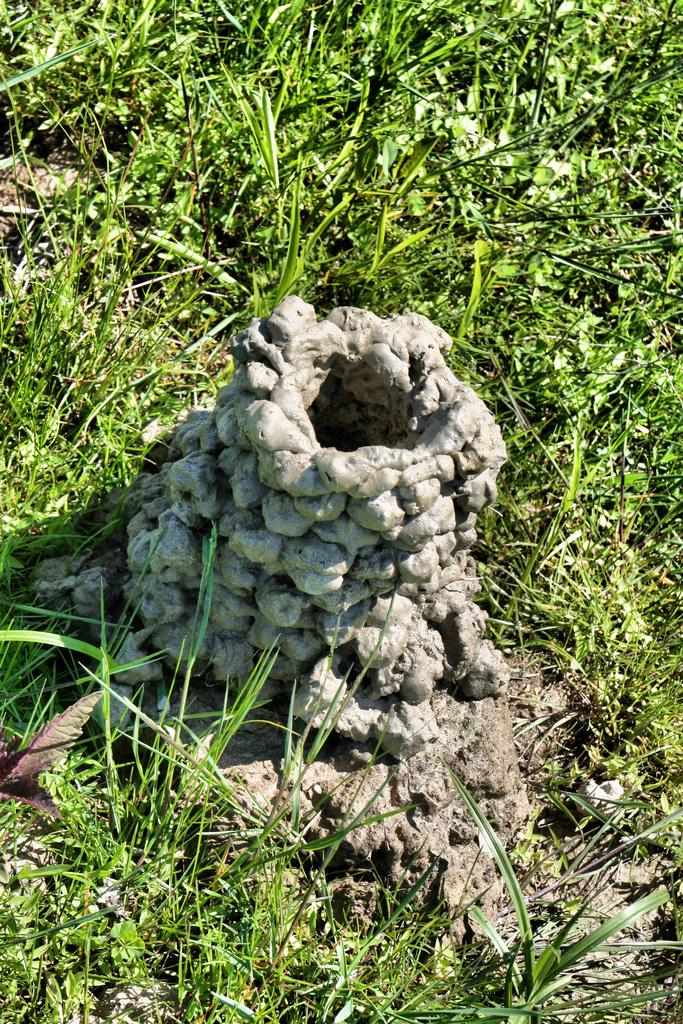What type of hole is visible in the image? There is a mud-made hole in the image. Where is the hole located? The hole is on a grass surface area. What type of shoe is being delivered by the coach in the image? There is no shoe or coach present in the image; it only features a mud-made hole on a grass surface area. 